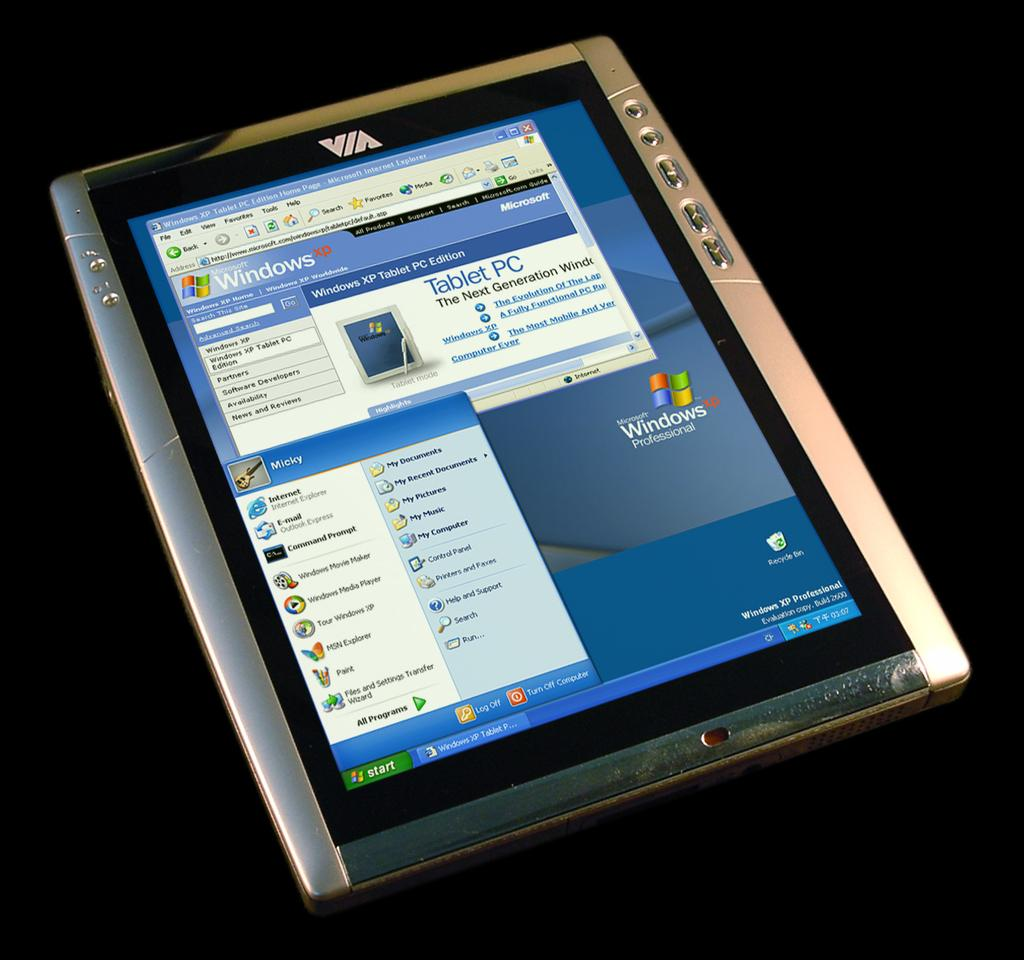What electronic device is present in the image? There is a tablet computer in the image. What feature of the tablet computer is visible? The tablet computer has a display. What can be seen on the display of the tablet computer? There is text visible on the display. What is the color of the background in the image? The background of the image is dark. How many pizzas are being played on the tablet computer in the image? There are no pizzas being played on the tablet computer in the image; it is displaying text. What type of music can be heard coming from the toy in the image? There is no toy present in the image, so it is not possible to determine what type of music might be heard. 